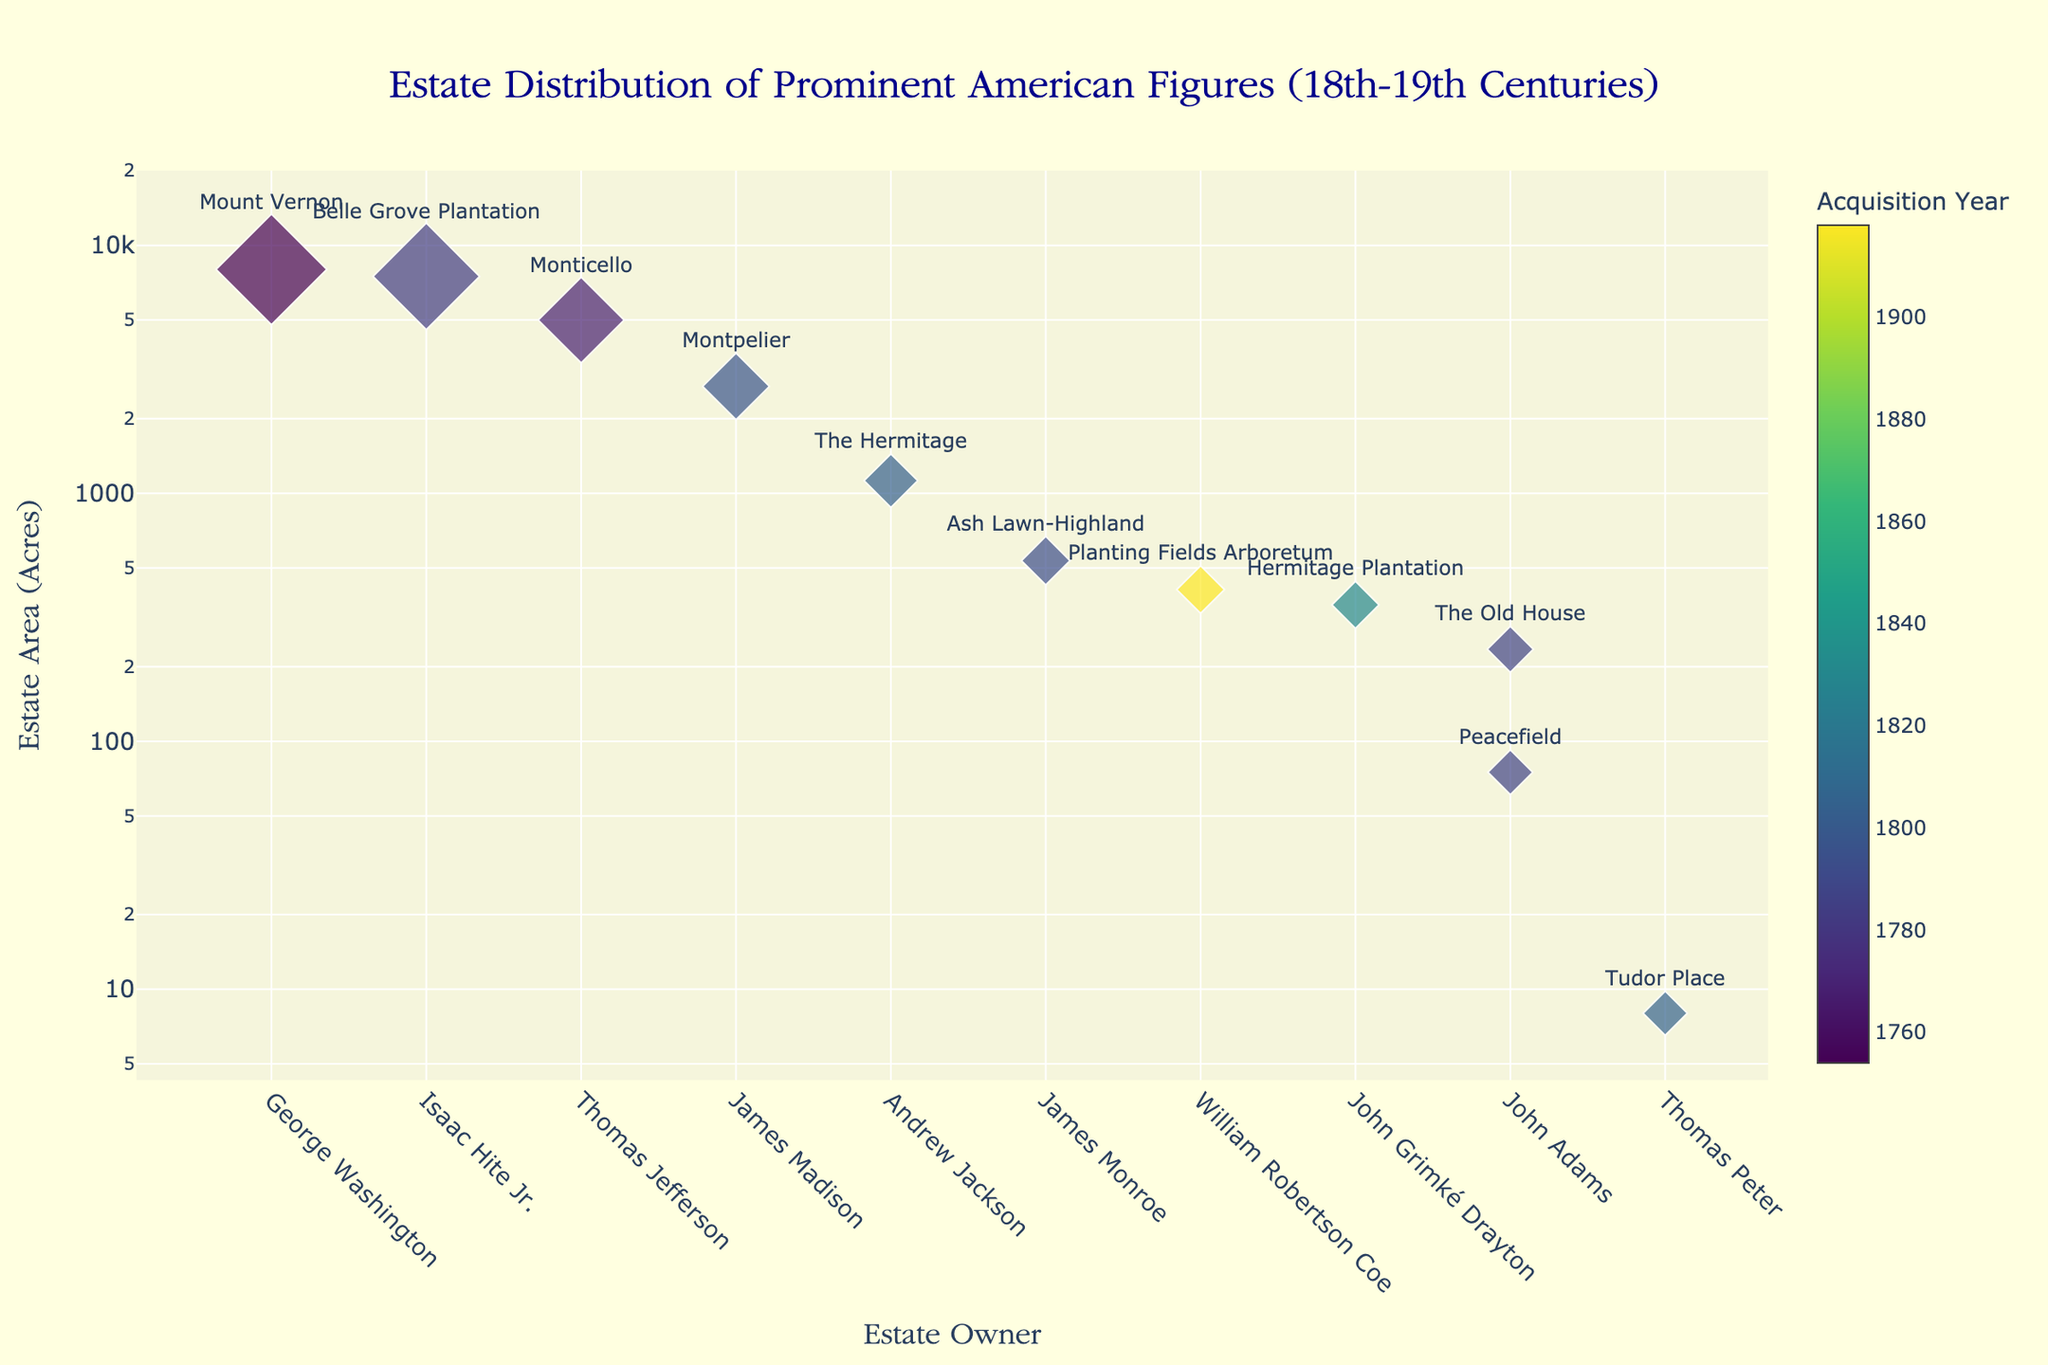What's the title of the figure? The title is at the top of the figure and describes the distribution of estates among prominent American figures in the 18th-19th centuries.
Answer: Estate Distribution of Prominent American Figures (18th-19th Centuries) Which estate has the smallest area? The smallest area is represented by the smallest marker size on the y-axis with the smallest quantity on the log scale, located at Tudor Place.
Answer: Tudor Place How many estates are represented in the figure? By counting the number of unique markers (each represents an estate), it is possible to determine the total number of estates on the plot.
Answer: 11 Which estate owners have estates larger than 5000 acres? On the y-axis with a log scale, identify markers that are above the 5000-acre mark and note the corresponding estate owners along the x-axis. These owners are George Washington and Isaac Hite Jr.
Answer: George Washington and Isaac Hite Jr Compare the estate areas of Thomas Jefferson and James Monroe. Who had a larger estate? Locate markers for both Thomas Jefferson (Monticello) and James Monroe (Ash Lawn-Highland) on the y-axis and compare their positions. Jefferson's Monticello is situated higher on the log scale, indicating a larger area.
Answer: Thomas Jefferson What color represents the earliest acquisition year on the color scale? The earliest acquisition year can be identified by the marker with the darkest color on the scale (Viridis), which is Mount Vernon (1754).
Answer: Dark color (Greenish) What is the approximate area of Montpelier? Find Montpelier’s marker and read off its location on the y-axis log scale. Montpelier is slightly below the 3000-acre mark, which indicates an area of around 2700 acres.
Answer: 2700 acres Which figure acquired their estate in 1783 and what is the estate's area? Identify the marker corresponding to the color for the year 1783 on the color scale and note the associated estate and its area. This is Belle Grove Plantation with an area of 7500 acres.
Answer: Isaac Hite Jr., 7500 acres Are there more estates acquired before 1800 or after 1800? Count the number of markers, dividing them by the acquisition year, to determine which period has more estates. More estates were acquired before 1800.
Answer: Before 1800 What is the median estate area among all the estates represented in the figure? List all estate areas in ascending order: 8, 75, 235, 355, 409, 535, 1125, 2700, 5000, 7500, 8000. The median is the sixth value in an ordered data set with 11 values, which is 535 acres (Ash Lawn-Highland).
Answer: 535 acres (Ash Lawn-Highland) 